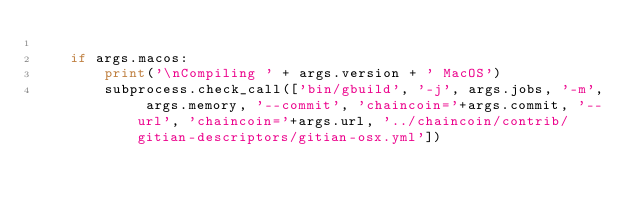Convert code to text. <code><loc_0><loc_0><loc_500><loc_500><_Python_>
    if args.macos:
        print('\nCompiling ' + args.version + ' MacOS')
        subprocess.check_call(['bin/gbuild', '-j', args.jobs, '-m', args.memory, '--commit', 'chaincoin='+args.commit, '--url', 'chaincoin='+args.url, '../chaincoin/contrib/gitian-descriptors/gitian-osx.yml'])</code> 